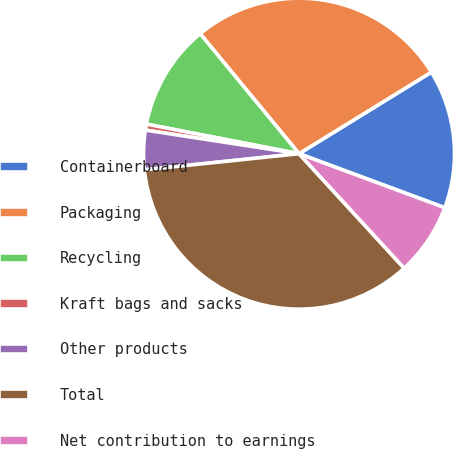Convert chart. <chart><loc_0><loc_0><loc_500><loc_500><pie_chart><fcel>Containerboard<fcel>Packaging<fcel>Recycling<fcel>Kraft bags and sacks<fcel>Other products<fcel>Total<fcel>Net contribution to earnings<nl><fcel>14.44%<fcel>27.18%<fcel>10.99%<fcel>0.62%<fcel>4.08%<fcel>35.17%<fcel>7.53%<nl></chart> 